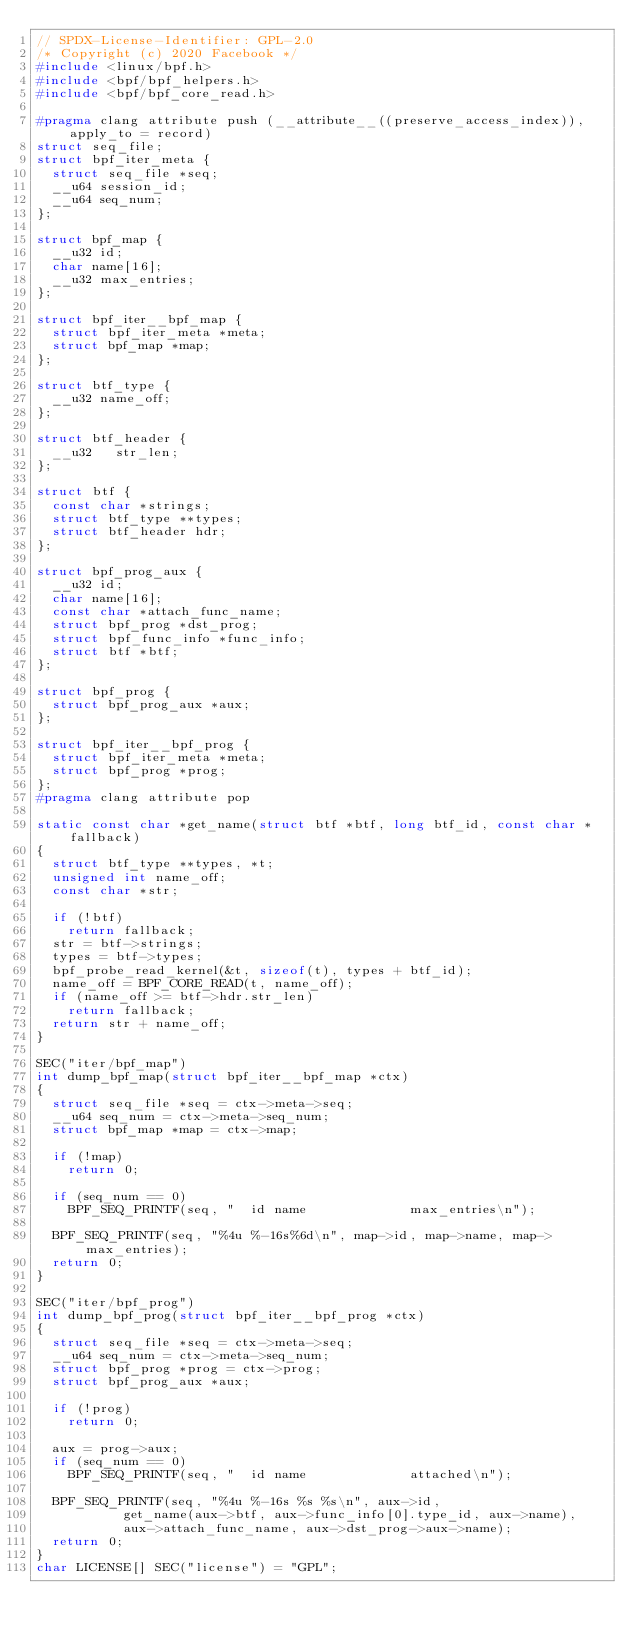Convert code to text. <code><loc_0><loc_0><loc_500><loc_500><_C_>// SPDX-License-Identifier: GPL-2.0
/* Copyright (c) 2020 Facebook */
#include <linux/bpf.h>
#include <bpf/bpf_helpers.h>
#include <bpf/bpf_core_read.h>

#pragma clang attribute push (__attribute__((preserve_access_index)), apply_to = record)
struct seq_file;
struct bpf_iter_meta {
	struct seq_file *seq;
	__u64 session_id;
	__u64 seq_num;
};

struct bpf_map {
	__u32 id;
	char name[16];
	__u32 max_entries;
};

struct bpf_iter__bpf_map {
	struct bpf_iter_meta *meta;
	struct bpf_map *map;
};

struct btf_type {
	__u32 name_off;
};

struct btf_header {
	__u32   str_len;
};

struct btf {
	const char *strings;
	struct btf_type **types;
	struct btf_header hdr;
};

struct bpf_prog_aux {
	__u32 id;
	char name[16];
	const char *attach_func_name;
	struct bpf_prog *dst_prog;
	struct bpf_func_info *func_info;
	struct btf *btf;
};

struct bpf_prog {
	struct bpf_prog_aux *aux;
};

struct bpf_iter__bpf_prog {
	struct bpf_iter_meta *meta;
	struct bpf_prog *prog;
};
#pragma clang attribute pop

static const char *get_name(struct btf *btf, long btf_id, const char *fallback)
{
	struct btf_type **types, *t;
	unsigned int name_off;
	const char *str;

	if (!btf)
		return fallback;
	str = btf->strings;
	types = btf->types;
	bpf_probe_read_kernel(&t, sizeof(t), types + btf_id);
	name_off = BPF_CORE_READ(t, name_off);
	if (name_off >= btf->hdr.str_len)
		return fallback;
	return str + name_off;
}

SEC("iter/bpf_map")
int dump_bpf_map(struct bpf_iter__bpf_map *ctx)
{
	struct seq_file *seq = ctx->meta->seq;
	__u64 seq_num = ctx->meta->seq_num;
	struct bpf_map *map = ctx->map;

	if (!map)
		return 0;

	if (seq_num == 0)
		BPF_SEQ_PRINTF(seq, "  id name             max_entries\n");

	BPF_SEQ_PRINTF(seq, "%4u %-16s%6d\n", map->id, map->name, map->max_entries);
	return 0;
}

SEC("iter/bpf_prog")
int dump_bpf_prog(struct bpf_iter__bpf_prog *ctx)
{
	struct seq_file *seq = ctx->meta->seq;
	__u64 seq_num = ctx->meta->seq_num;
	struct bpf_prog *prog = ctx->prog;
	struct bpf_prog_aux *aux;

	if (!prog)
		return 0;

	aux = prog->aux;
	if (seq_num == 0)
		BPF_SEQ_PRINTF(seq, "  id name             attached\n");

	BPF_SEQ_PRINTF(seq, "%4u %-16s %s %s\n", aux->id,
		       get_name(aux->btf, aux->func_info[0].type_id, aux->name),
		       aux->attach_func_name, aux->dst_prog->aux->name);
	return 0;
}
char LICENSE[] SEC("license") = "GPL";
</code> 